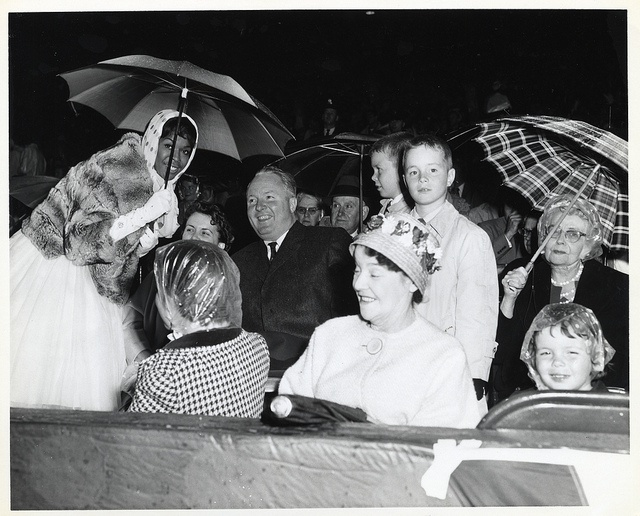Describe the objects in this image and their specific colors. I can see people in ivory, lightgray, darkgray, gray, and black tones, people in ivory, lightgray, darkgray, gray, and black tones, people in ivory, lightgray, gray, darkgray, and black tones, people in ivory, black, darkgray, gray, and lightgray tones, and people in ivory, black, darkgray, gray, and lightgray tones in this image. 